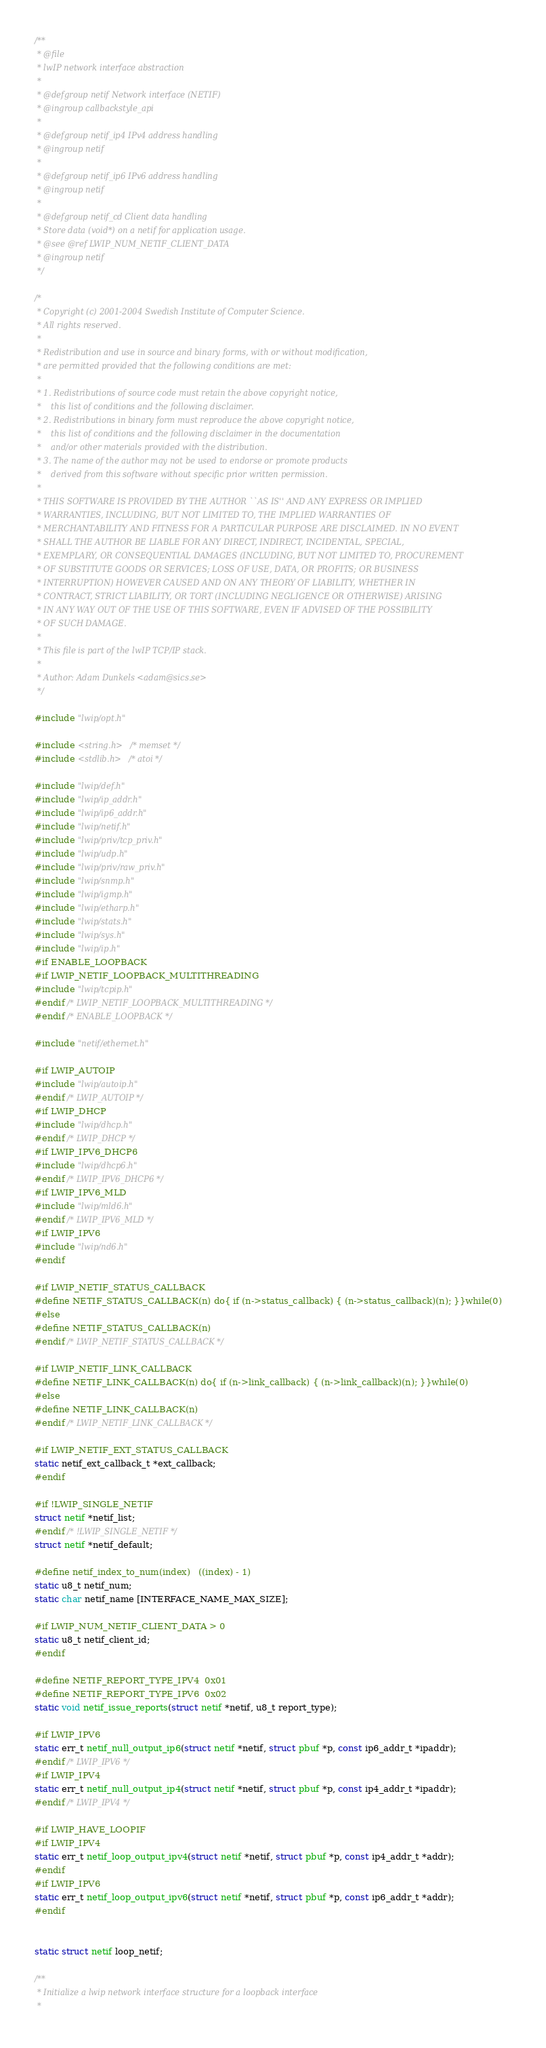<code> <loc_0><loc_0><loc_500><loc_500><_C_>/**
 * @file
 * lwIP network interface abstraction
 *
 * @defgroup netif Network interface (NETIF)
 * @ingroup callbackstyle_api
 *
 * @defgroup netif_ip4 IPv4 address handling
 * @ingroup netif
 *
 * @defgroup netif_ip6 IPv6 address handling
 * @ingroup netif
 *
 * @defgroup netif_cd Client data handling
 * Store data (void*) on a netif for application usage.
 * @see @ref LWIP_NUM_NETIF_CLIENT_DATA
 * @ingroup netif
 */

/*
 * Copyright (c) 2001-2004 Swedish Institute of Computer Science.
 * All rights reserved.
 *
 * Redistribution and use in source and binary forms, with or without modification,
 * are permitted provided that the following conditions are met:
 *
 * 1. Redistributions of source code must retain the above copyright notice,
 *    this list of conditions and the following disclaimer.
 * 2. Redistributions in binary form must reproduce the above copyright notice,
 *    this list of conditions and the following disclaimer in the documentation
 *    and/or other materials provided with the distribution.
 * 3. The name of the author may not be used to endorse or promote products
 *    derived from this software without specific prior written permission.
 *
 * THIS SOFTWARE IS PROVIDED BY THE AUTHOR ``AS IS'' AND ANY EXPRESS OR IMPLIED
 * WARRANTIES, INCLUDING, BUT NOT LIMITED TO, THE IMPLIED WARRANTIES OF
 * MERCHANTABILITY AND FITNESS FOR A PARTICULAR PURPOSE ARE DISCLAIMED. IN NO EVENT
 * SHALL THE AUTHOR BE LIABLE FOR ANY DIRECT, INDIRECT, INCIDENTAL, SPECIAL,
 * EXEMPLARY, OR CONSEQUENTIAL DAMAGES (INCLUDING, BUT NOT LIMITED TO, PROCUREMENT
 * OF SUBSTITUTE GOODS OR SERVICES; LOSS OF USE, DATA, OR PROFITS; OR BUSINESS
 * INTERRUPTION) HOWEVER CAUSED AND ON ANY THEORY OF LIABILITY, WHETHER IN
 * CONTRACT, STRICT LIABILITY, OR TORT (INCLUDING NEGLIGENCE OR OTHERWISE) ARISING
 * IN ANY WAY OUT OF THE USE OF THIS SOFTWARE, EVEN IF ADVISED OF THE POSSIBILITY
 * OF SUCH DAMAGE.
 *
 * This file is part of the lwIP TCP/IP stack.
 *
 * Author: Adam Dunkels <adam@sics.se>
 */

#include "lwip/opt.h"

#include <string.h> /* memset */
#include <stdlib.h> /* atoi */

#include "lwip/def.h"
#include "lwip/ip_addr.h"
#include "lwip/ip6_addr.h"
#include "lwip/netif.h"
#include "lwip/priv/tcp_priv.h"
#include "lwip/udp.h"
#include "lwip/priv/raw_priv.h"
#include "lwip/snmp.h"
#include "lwip/igmp.h"
#include "lwip/etharp.h"
#include "lwip/stats.h"
#include "lwip/sys.h"
#include "lwip/ip.h"
#if ENABLE_LOOPBACK
#if LWIP_NETIF_LOOPBACK_MULTITHREADING
#include "lwip/tcpip.h"
#endif /* LWIP_NETIF_LOOPBACK_MULTITHREADING */
#endif /* ENABLE_LOOPBACK */

#include "netif/ethernet.h"

#if LWIP_AUTOIP
#include "lwip/autoip.h"
#endif /* LWIP_AUTOIP */
#if LWIP_DHCP
#include "lwip/dhcp.h"
#endif /* LWIP_DHCP */
#if LWIP_IPV6_DHCP6
#include "lwip/dhcp6.h"
#endif /* LWIP_IPV6_DHCP6 */
#if LWIP_IPV6_MLD
#include "lwip/mld6.h"
#endif /* LWIP_IPV6_MLD */
#if LWIP_IPV6
#include "lwip/nd6.h"
#endif

#if LWIP_NETIF_STATUS_CALLBACK
#define NETIF_STATUS_CALLBACK(n) do{ if (n->status_callback) { (n->status_callback)(n); }}while(0)
#else
#define NETIF_STATUS_CALLBACK(n)
#endif /* LWIP_NETIF_STATUS_CALLBACK */

#if LWIP_NETIF_LINK_CALLBACK
#define NETIF_LINK_CALLBACK(n) do{ if (n->link_callback) { (n->link_callback)(n); }}while(0)
#else
#define NETIF_LINK_CALLBACK(n)
#endif /* LWIP_NETIF_LINK_CALLBACK */

#if LWIP_NETIF_EXT_STATUS_CALLBACK
static netif_ext_callback_t *ext_callback;
#endif

#if !LWIP_SINGLE_NETIF
struct netif *netif_list;
#endif /* !LWIP_SINGLE_NETIF */
struct netif *netif_default;

#define netif_index_to_num(index)   ((index) - 1)
static u8_t netif_num;
static char netif_name [INTERFACE_NAME_MAX_SIZE];

#if LWIP_NUM_NETIF_CLIENT_DATA > 0
static u8_t netif_client_id;
#endif

#define NETIF_REPORT_TYPE_IPV4  0x01
#define NETIF_REPORT_TYPE_IPV6  0x02
static void netif_issue_reports(struct netif *netif, u8_t report_type);

#if LWIP_IPV6
static err_t netif_null_output_ip6(struct netif *netif, struct pbuf *p, const ip6_addr_t *ipaddr);
#endif /* LWIP_IPV6 */
#if LWIP_IPV4
static err_t netif_null_output_ip4(struct netif *netif, struct pbuf *p, const ip4_addr_t *ipaddr);
#endif /* LWIP_IPV4 */

#if LWIP_HAVE_LOOPIF
#if LWIP_IPV4
static err_t netif_loop_output_ipv4(struct netif *netif, struct pbuf *p, const ip4_addr_t *addr);
#endif
#if LWIP_IPV6
static err_t netif_loop_output_ipv6(struct netif *netif, struct pbuf *p, const ip6_addr_t *addr);
#endif


static struct netif loop_netif;

/**
 * Initialize a lwip network interface structure for a loopback interface
 *</code> 